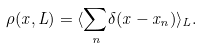Convert formula to latex. <formula><loc_0><loc_0><loc_500><loc_500>\rho ( x , L ) = \langle { \sum _ { n } } \delta ( x - x _ { n } ) \rangle _ { L } .</formula> 